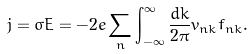<formula> <loc_0><loc_0><loc_500><loc_500>j = \sigma E = - 2 e \sum _ { n } \int _ { - \infty } ^ { \infty } \frac { d k } { 2 \pi } v _ { n k } f _ { n k } .</formula> 